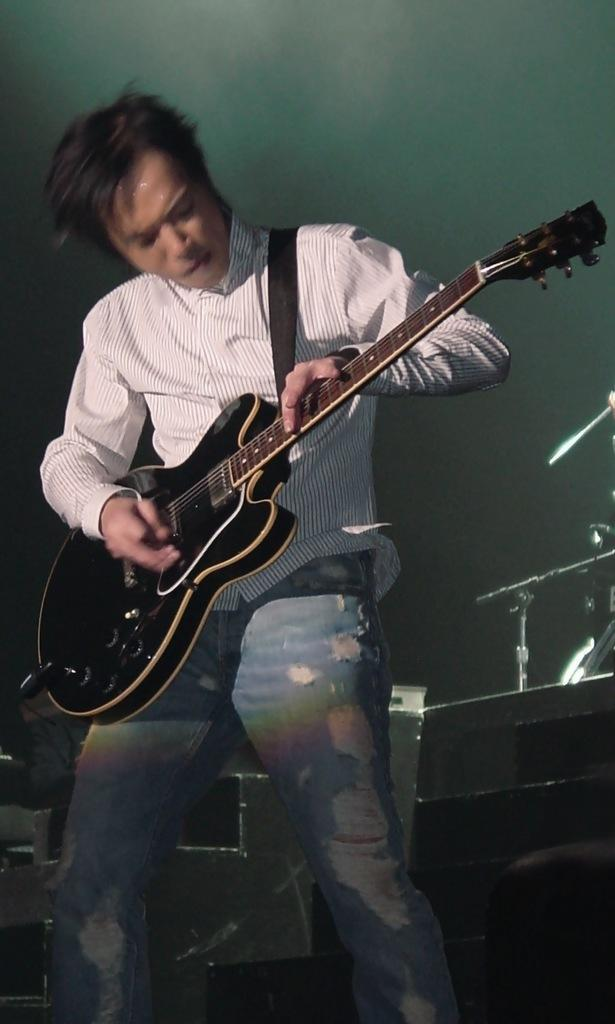Who is the main subject in the image? There is a man in the image. Where is the man located in the image? The man is in the middle of the image. What is the man wearing in the image? The man is wearing a shirt and trousers. What is the man doing in the image? The man is playing a guitar. What type of waves can be seen crashing on the shore in the image? There are no waves or shore visible in the image; it features a man playing a guitar. 